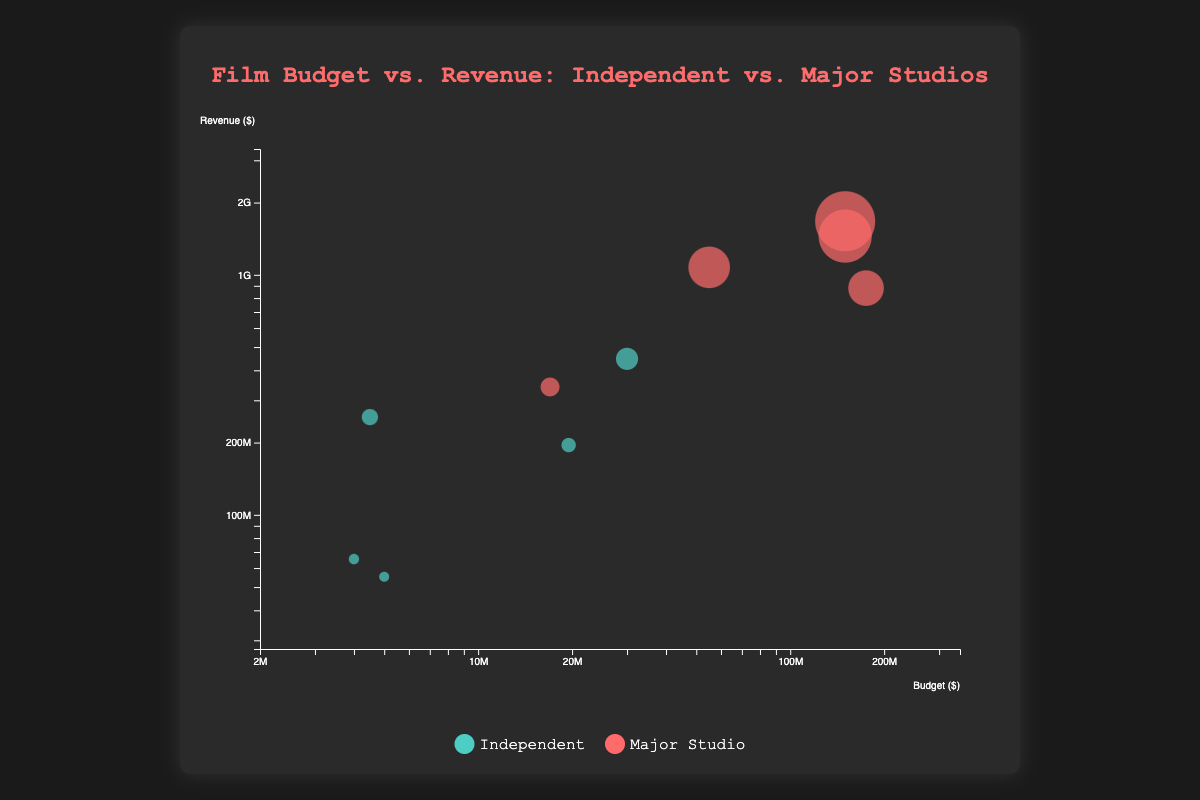What are the axes labels? The x-axis is labeled "Budget ($)" indicating film budgets, and the y-axis is labeled "Revenue ($)" indicating film revenues.
Answer: Budget ($) and Revenue ($) How many films represented are produced by independent studios? By counting the colors corresponding to independent studios (cyan) in the bubbles, we find there are 5 films: Moonlight, The Shape of Water, La La Land, Get Out, and Dallas Buyers Club.
Answer: 5 Which movie has the highest revenue, and what is its budget? The movie with the highest revenue is represented by the largest bubble at the top of the chart. It is Jurassic World with a revenue of $1,671,713,208 and a budget of $150,000,000.
Answer: Jurassic World, $150,000,000 What is the range of the budgets for the independent films? The budgets for the independent films can be observed by looking at the placements of cyan-colored bubbles on the x-axis. The minimum budget is $4,000,000 (Moonlight) and the maximum is $30,000,000 (La La Land).
Answer: $4,000,000 to $30,000,000 Which film has the lowest ratio of budget to revenue? Divide each movie's revenue by its budget, then find the movie with the highest resulting ratio. Get Out has a budget of $4,500,000 and a revenue of $255,407,969, resulting in the lowest budget-to-revenue ratio of approximately 1:56.
Answer: Get Out Do independent or major studio films generally have higher budgets? By observing the x-axis placement and the colors of the bubbles, major studio films (red) generally have higher budgets compared to independent films (cyan).
Answer: Major studio films Which independent film has grossed the highest revenue, and what is the amount? Identify the highest cyan bubble on the y-axis. Get Out, produced by Blumhouse Productions, has the highest revenue among independent films with $255,407,969.
Answer: Get Out, $255,407,969 What is the median revenue of the films shown in the chart? Arrange all the revenues in ascending order: $55,200,000, $65,394,635, $195,243,980, $255,407,969, $340,952,897, $446,500,000, $880,166,924, $1,074,251,311, $1,450,026,933, $1,671,713,208. The median is the middle value of this ordered list, which is the average of the 5th and 6th values, ($340,952,897 + $446,500,000) / 2 = $393,726,448.50.
Answer: $393,726,448.50 Which movie produced by major studios has the smallest budget, and what is its revenue? Identify the smallest budget red bubble on the x-axis, which corresponds to A Quiet Place with a budget of $17,000,000 and revenue of $340,952,897.
Answer: A Quiet Place, $340,952,897 How does the average budget of major studio films compare to that of independent films? Calculate the average budget for each group (major studios and independents). Major studios' budgets: $55,000,000, $17,000,000, $150,000,000, $175,000,000, $150,000,000. Sum is $547,000,000. Divide by 5: $547,000,000 / 5 = $109,400,000. Independent films' budgets: $4,000,000, $19,500,000, $30,000,000, $4,500,000, $5,000,000. Sum is $63,000,000. Divide by 5: $63,000,000 / 5 = $12,600,000. The average budget of major studio films is significantly higher.
Answer: Major studio films have higher average budget 